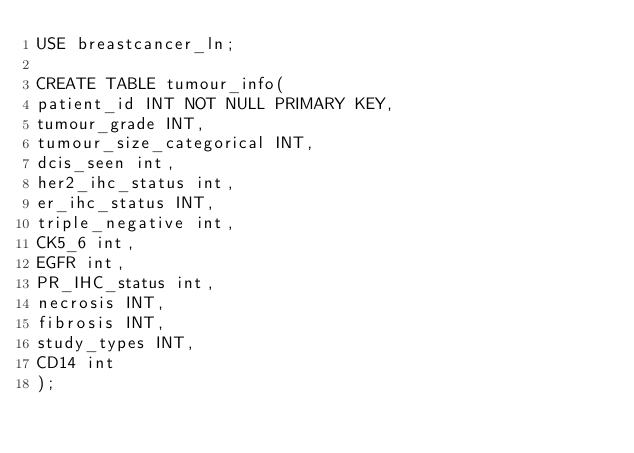<code> <loc_0><loc_0><loc_500><loc_500><_SQL_>USE breastcancer_ln;

CREATE TABLE tumour_info(
patient_id INT NOT NULL PRIMARY KEY,
tumour_grade INT,
tumour_size_categorical INT,
dcis_seen int,
her2_ihc_status int,
er_ihc_status INT,
triple_negative int,
CK5_6 int,
EGFR int,
PR_IHC_status int,
necrosis INT,
fibrosis INT,
study_types INT,
CD14 int
);






</code> 